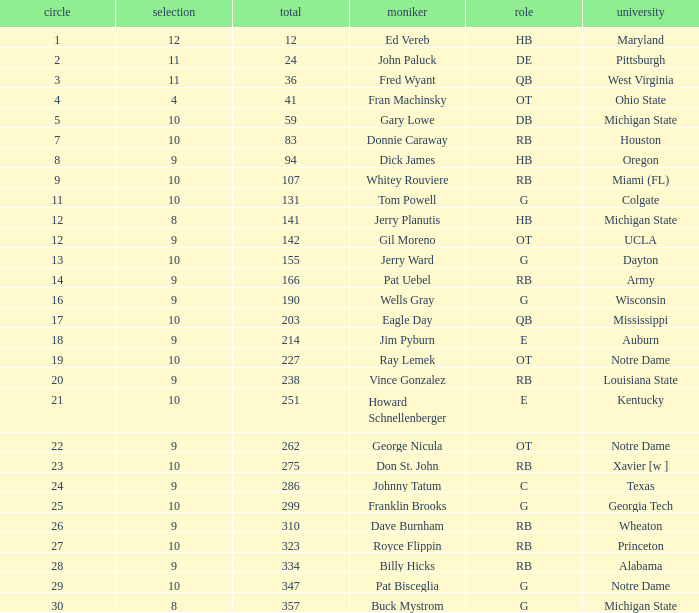What is the highest overall pick number for george nicula who had a pick smaller than 9? None. 